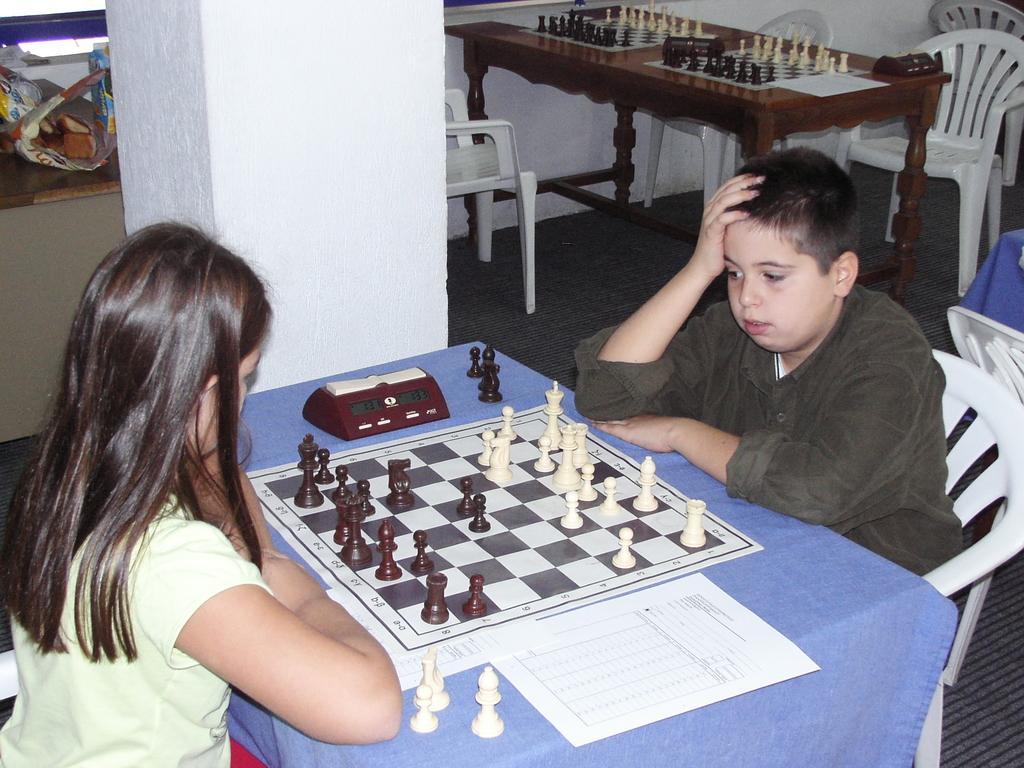How would you summarize this image in a sentence or two? In this Image i see a boy and a girl who are sitting on chairs and there are tables on which there are chess boards, few devices and a paper on the table. In the background I see chairs and the wall. 